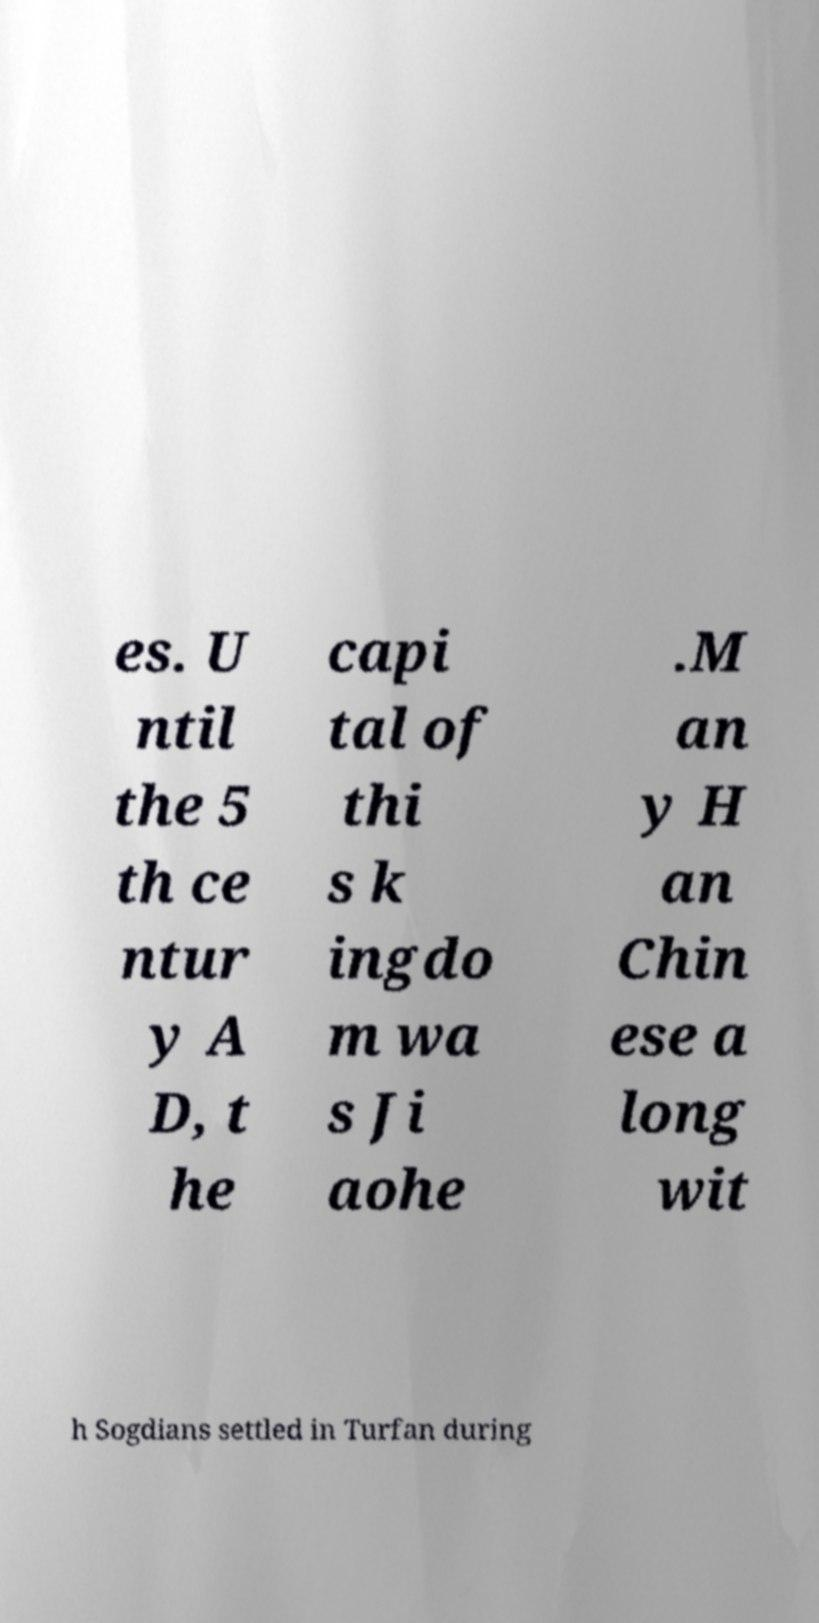Can you read and provide the text displayed in the image?This photo seems to have some interesting text. Can you extract and type it out for me? es. U ntil the 5 th ce ntur y A D, t he capi tal of thi s k ingdo m wa s Ji aohe .M an y H an Chin ese a long wit h Sogdians settled in Turfan during 